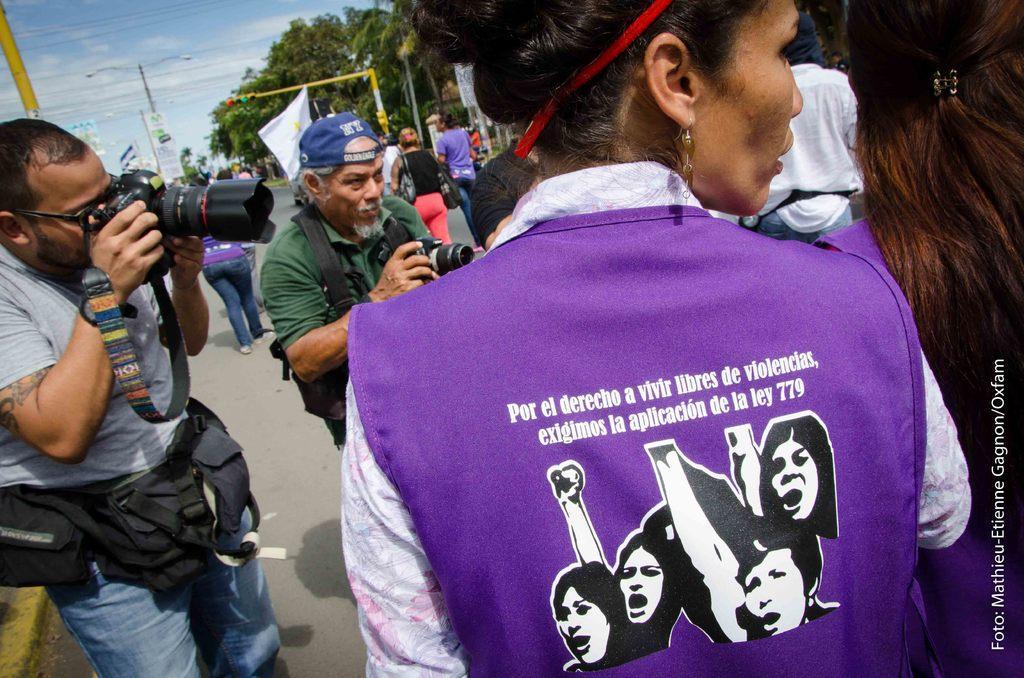Please provide a concise description of this image. In this picture we can see 2 people holding cameras and looking at someone. There are many other people on the road surrounded by trees. The sky is blue. 